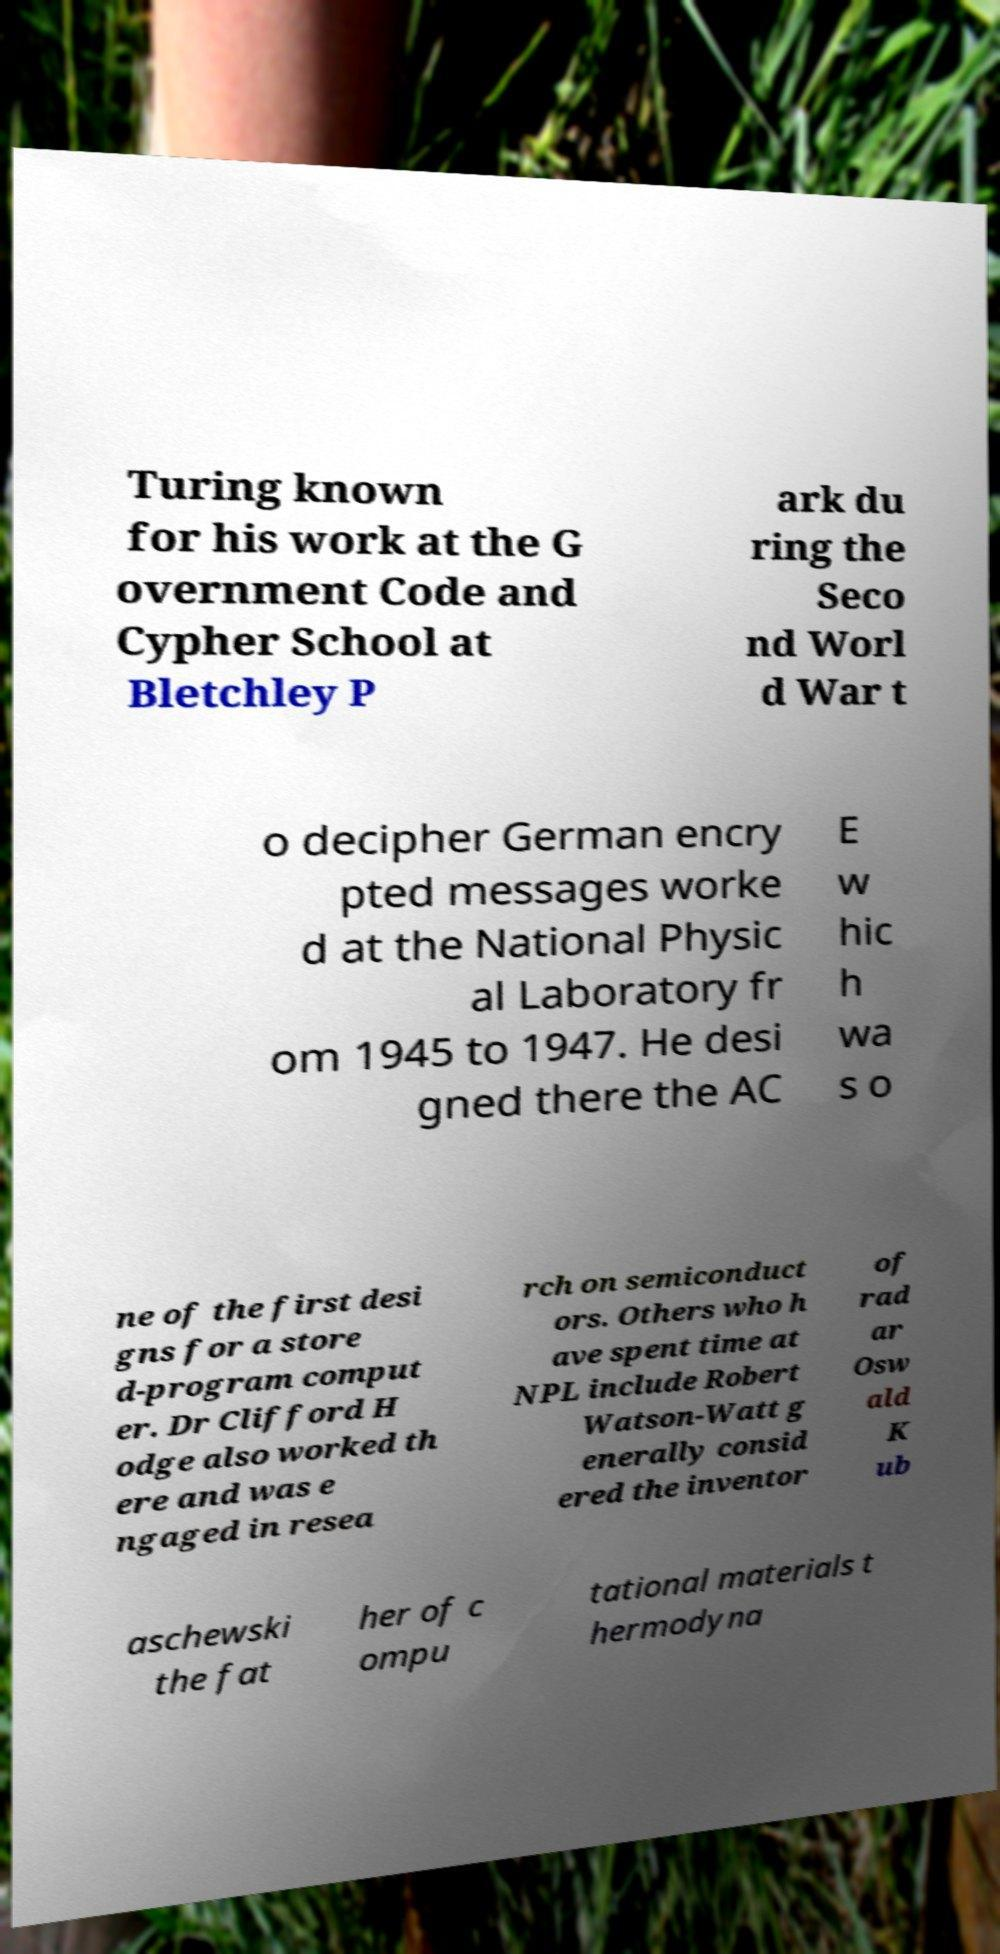Please identify and transcribe the text found in this image. Turing known for his work at the G overnment Code and Cypher School at Bletchley P ark du ring the Seco nd Worl d War t o decipher German encry pted messages worke d at the National Physic al Laboratory fr om 1945 to 1947. He desi gned there the AC E w hic h wa s o ne of the first desi gns for a store d-program comput er. Dr Clifford H odge also worked th ere and was e ngaged in resea rch on semiconduct ors. Others who h ave spent time at NPL include Robert Watson-Watt g enerally consid ered the inventor of rad ar Osw ald K ub aschewski the fat her of c ompu tational materials t hermodyna 